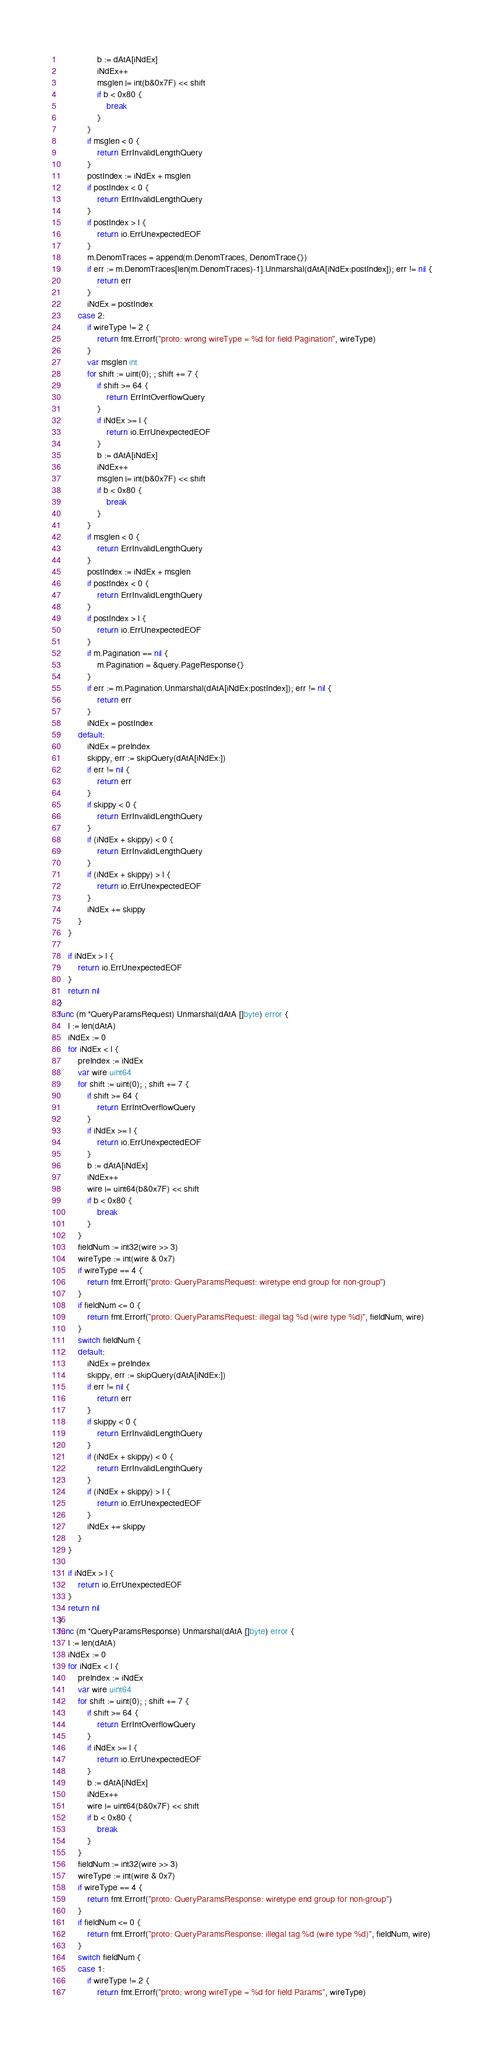<code> <loc_0><loc_0><loc_500><loc_500><_Go_>				b := dAtA[iNdEx]
				iNdEx++
				msglen |= int(b&0x7F) << shift
				if b < 0x80 {
					break
				}
			}
			if msglen < 0 {
				return ErrInvalidLengthQuery
			}
			postIndex := iNdEx + msglen
			if postIndex < 0 {
				return ErrInvalidLengthQuery
			}
			if postIndex > l {
				return io.ErrUnexpectedEOF
			}
			m.DenomTraces = append(m.DenomTraces, DenomTrace{})
			if err := m.DenomTraces[len(m.DenomTraces)-1].Unmarshal(dAtA[iNdEx:postIndex]); err != nil {
				return err
			}
			iNdEx = postIndex
		case 2:
			if wireType != 2 {
				return fmt.Errorf("proto: wrong wireType = %d for field Pagination", wireType)
			}
			var msglen int
			for shift := uint(0); ; shift += 7 {
				if shift >= 64 {
					return ErrIntOverflowQuery
				}
				if iNdEx >= l {
					return io.ErrUnexpectedEOF
				}
				b := dAtA[iNdEx]
				iNdEx++
				msglen |= int(b&0x7F) << shift
				if b < 0x80 {
					break
				}
			}
			if msglen < 0 {
				return ErrInvalidLengthQuery
			}
			postIndex := iNdEx + msglen
			if postIndex < 0 {
				return ErrInvalidLengthQuery
			}
			if postIndex > l {
				return io.ErrUnexpectedEOF
			}
			if m.Pagination == nil {
				m.Pagination = &query.PageResponse{}
			}
			if err := m.Pagination.Unmarshal(dAtA[iNdEx:postIndex]); err != nil {
				return err
			}
			iNdEx = postIndex
		default:
			iNdEx = preIndex
			skippy, err := skipQuery(dAtA[iNdEx:])
			if err != nil {
				return err
			}
			if skippy < 0 {
				return ErrInvalidLengthQuery
			}
			if (iNdEx + skippy) < 0 {
				return ErrInvalidLengthQuery
			}
			if (iNdEx + skippy) > l {
				return io.ErrUnexpectedEOF
			}
			iNdEx += skippy
		}
	}

	if iNdEx > l {
		return io.ErrUnexpectedEOF
	}
	return nil
}
func (m *QueryParamsRequest) Unmarshal(dAtA []byte) error {
	l := len(dAtA)
	iNdEx := 0
	for iNdEx < l {
		preIndex := iNdEx
		var wire uint64
		for shift := uint(0); ; shift += 7 {
			if shift >= 64 {
				return ErrIntOverflowQuery
			}
			if iNdEx >= l {
				return io.ErrUnexpectedEOF
			}
			b := dAtA[iNdEx]
			iNdEx++
			wire |= uint64(b&0x7F) << shift
			if b < 0x80 {
				break
			}
		}
		fieldNum := int32(wire >> 3)
		wireType := int(wire & 0x7)
		if wireType == 4 {
			return fmt.Errorf("proto: QueryParamsRequest: wiretype end group for non-group")
		}
		if fieldNum <= 0 {
			return fmt.Errorf("proto: QueryParamsRequest: illegal tag %d (wire type %d)", fieldNum, wire)
		}
		switch fieldNum {
		default:
			iNdEx = preIndex
			skippy, err := skipQuery(dAtA[iNdEx:])
			if err != nil {
				return err
			}
			if skippy < 0 {
				return ErrInvalidLengthQuery
			}
			if (iNdEx + skippy) < 0 {
				return ErrInvalidLengthQuery
			}
			if (iNdEx + skippy) > l {
				return io.ErrUnexpectedEOF
			}
			iNdEx += skippy
		}
	}

	if iNdEx > l {
		return io.ErrUnexpectedEOF
	}
	return nil
}
func (m *QueryParamsResponse) Unmarshal(dAtA []byte) error {
	l := len(dAtA)
	iNdEx := 0
	for iNdEx < l {
		preIndex := iNdEx
		var wire uint64
		for shift := uint(0); ; shift += 7 {
			if shift >= 64 {
				return ErrIntOverflowQuery
			}
			if iNdEx >= l {
				return io.ErrUnexpectedEOF
			}
			b := dAtA[iNdEx]
			iNdEx++
			wire |= uint64(b&0x7F) << shift
			if b < 0x80 {
				break
			}
		}
		fieldNum := int32(wire >> 3)
		wireType := int(wire & 0x7)
		if wireType == 4 {
			return fmt.Errorf("proto: QueryParamsResponse: wiretype end group for non-group")
		}
		if fieldNum <= 0 {
			return fmt.Errorf("proto: QueryParamsResponse: illegal tag %d (wire type %d)", fieldNum, wire)
		}
		switch fieldNum {
		case 1:
			if wireType != 2 {
				return fmt.Errorf("proto: wrong wireType = %d for field Params", wireType)</code> 